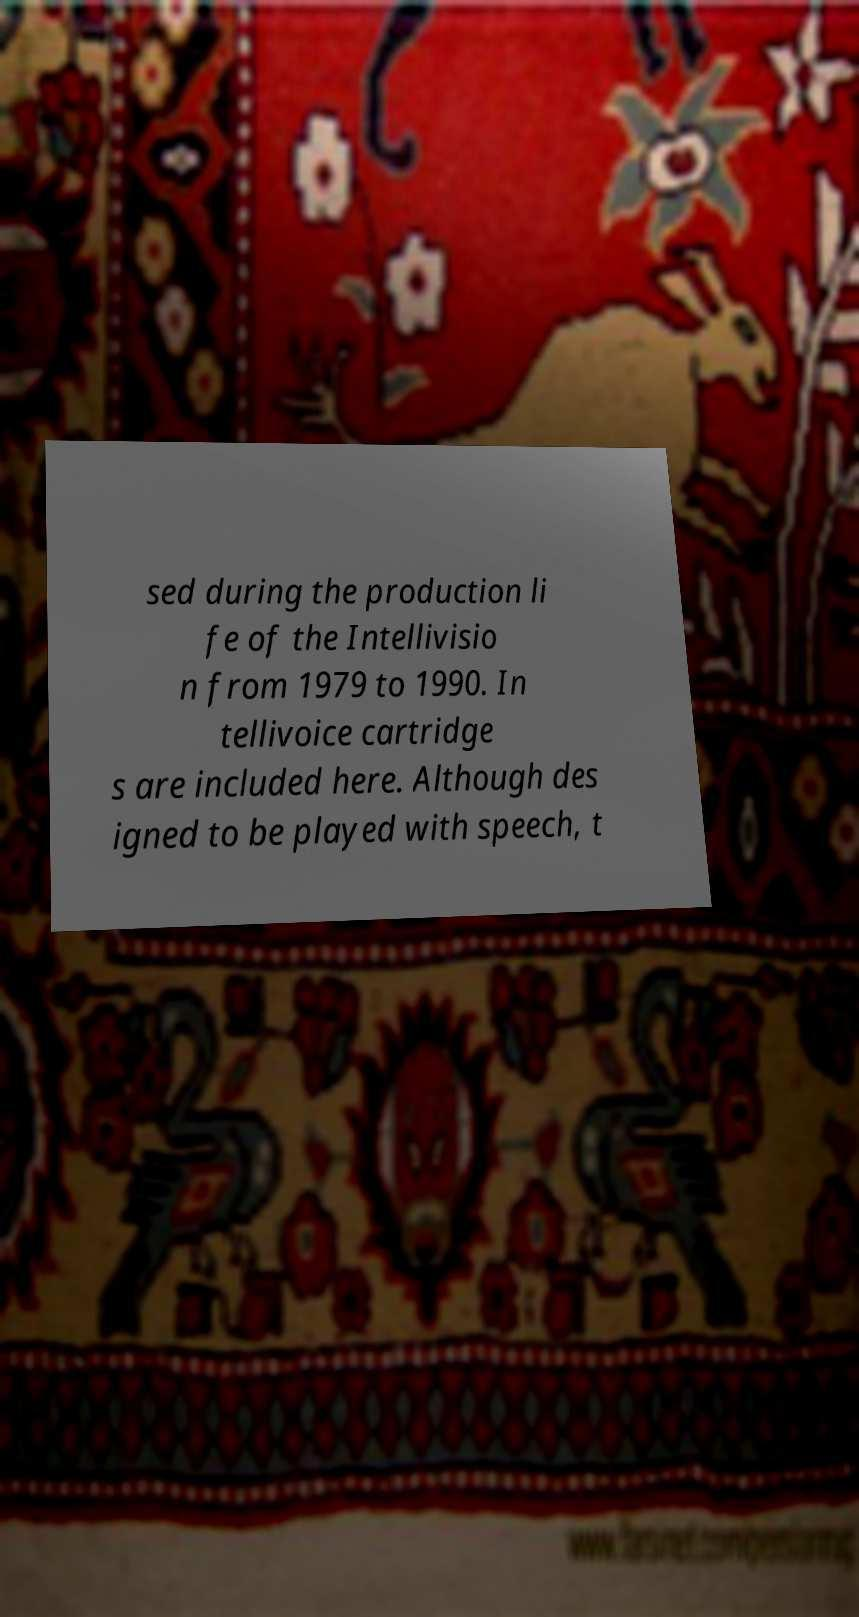Could you extract and type out the text from this image? sed during the production li fe of the Intellivisio n from 1979 to 1990. In tellivoice cartridge s are included here. Although des igned to be played with speech, t 